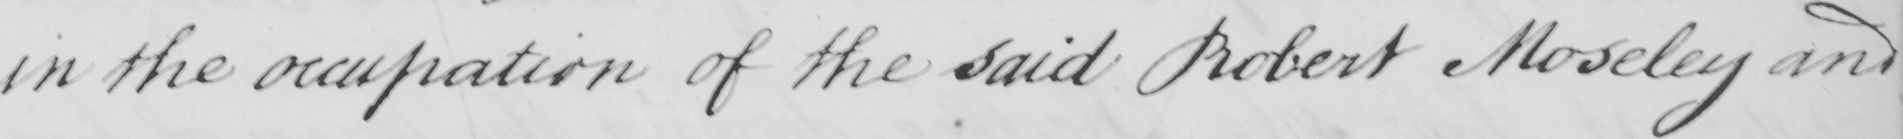What does this handwritten line say? in the occupation of the said Robert Moseley and 